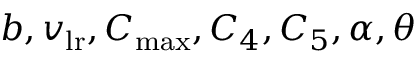<formula> <loc_0><loc_0><loc_500><loc_500>b , v _ { l r } , C _ { \max } , C _ { 4 } , C _ { 5 } , \alpha , \theta</formula> 